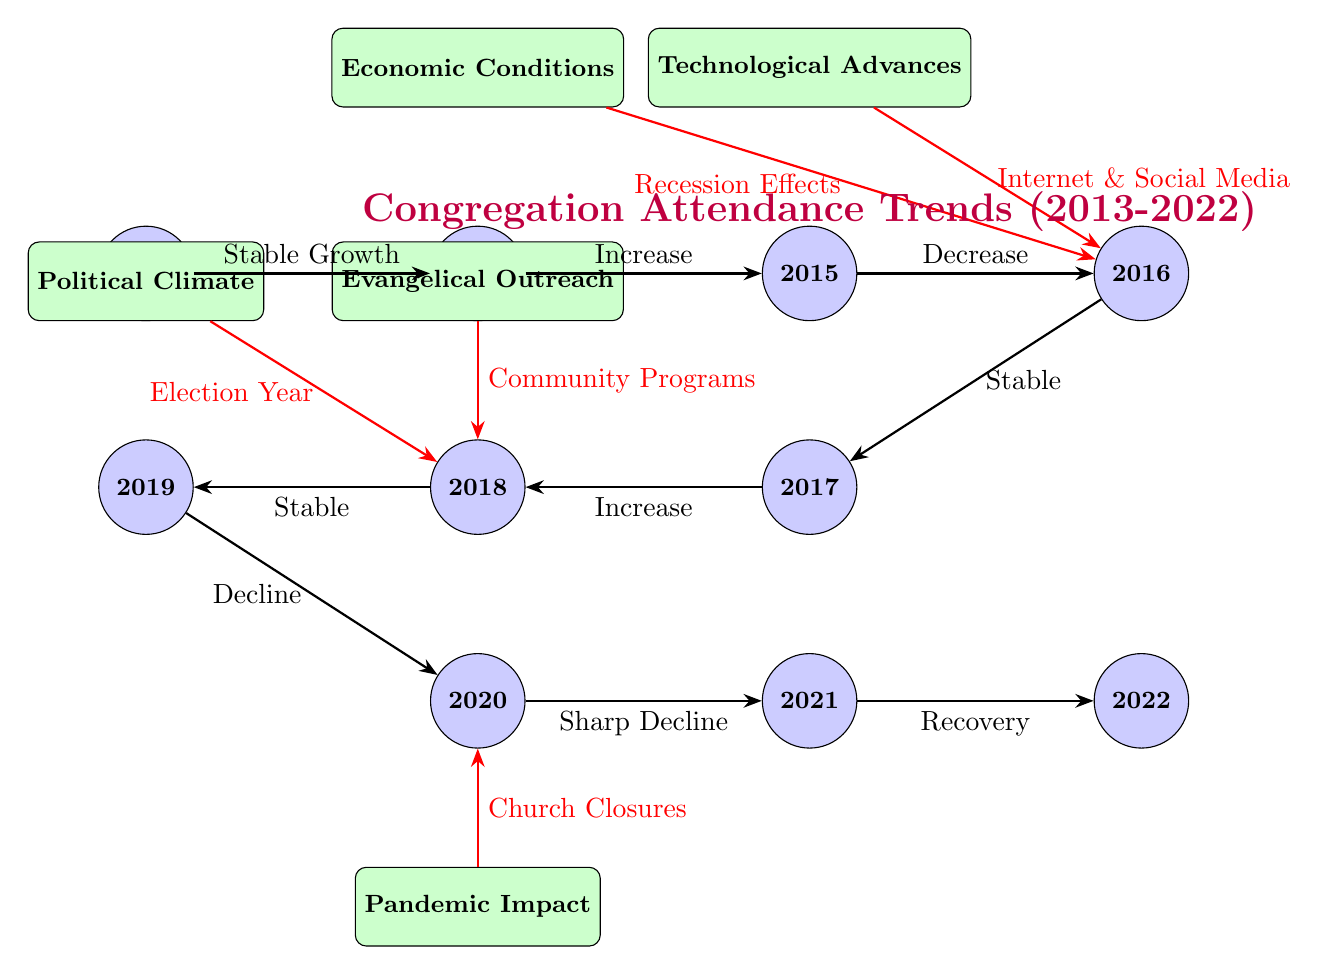What was the trend in attendance from 2015 to 2016? The diagram shows a decrease in attendance from 2015 to 2016. This is visually indicated by the directional edge from the 2015 node to the 2016 node labeled "Decrease."
Answer: Decrease Which year had a sharp decline in attendance? The diagram illustrates that the year with a sharp decline in attendance was 2020, as indicated by the label on the edge connecting 2020 and 2021 which states "Sharp Decline."
Answer: 2020 What was a key factor influencing attendance in 2016? The diagram highlights two key factors that influenced attendance in 2016: "Internet & Social Media" and "Recession Effects." Both factors are connected to the 2016 node via red edges.
Answer: Internet & Social Media, Recession Effects What trend occurred between 2017 and 2018? According to the diagram, there was an increase in attendance from 2017 to 2018, as indicated by the edge between the two nodes labeled "Increase."
Answer: Increase What external factor influenced attendance during the pandemic year? The diagram shows that during the pandemic year of 2020, the factor influencing attendance was "Church Closures," linked to the 2020 node.
Answer: Church Closures How many years are represented in the diagram? The diagram displays a total of ten years from 2013 to 2022, as counted by the yearly nodes present.
Answer: Ten What was the overall trend of attendance from 2013 to 2022? By examining the diagram, one can see that attendance overall exhibited fluctuations, starting with stable growth, peaking, and downtrends, then finally showing recovery by 2022. A conclusive interpretation indicates an overall fluctuation rather than a clear linear trend.
Answer: Fluctuation Which year experienced the highest level of attendance? Based on the diagram, one can infer that the year 2015 likely experienced the highest level of attendance, as it shows "Increase" going into that year from 2014, followed by a "Decrease" thereafter.
Answer: 2015 What effect did community programs have on attendance in 2018? The diagram indicates that community programs, labeled as "Evangelical Outreach," positively influenced attendance by connecting to the 2018 node with an edge labeled "Community Programs." This suggests a favorable impact.
Answer: Positive Influence 